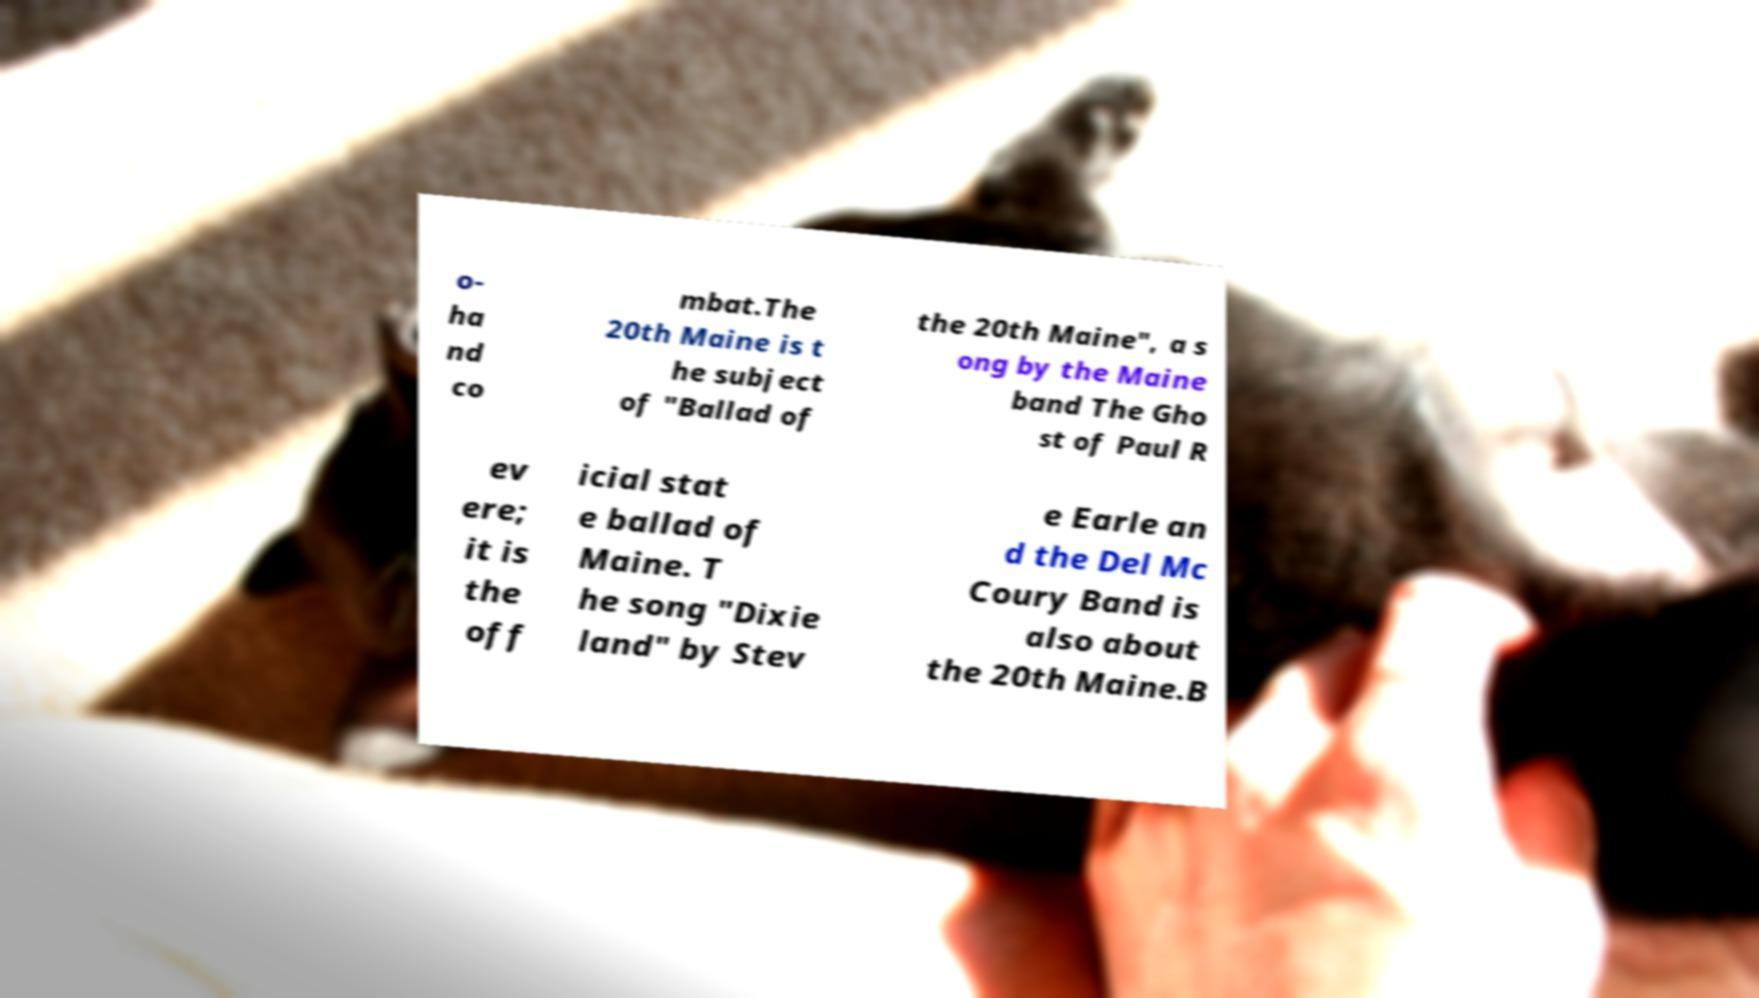Could you extract and type out the text from this image? o- ha nd co mbat.The 20th Maine is t he subject of "Ballad of the 20th Maine", a s ong by the Maine band The Gho st of Paul R ev ere; it is the off icial stat e ballad of Maine. T he song "Dixie land" by Stev e Earle an d the Del Mc Coury Band is also about the 20th Maine.B 